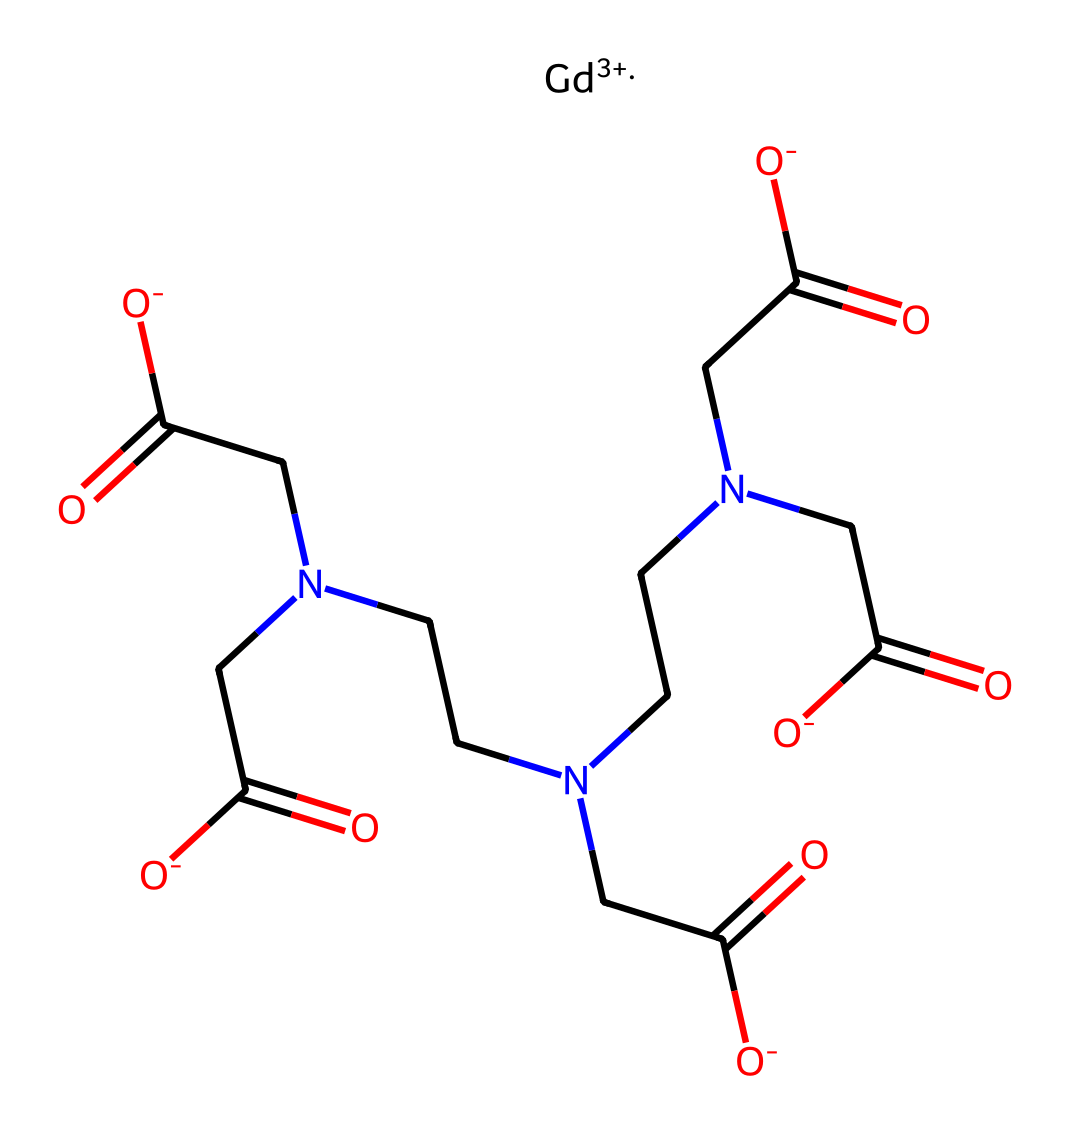How many nitrogen atoms are in the structure? The SMILES representation shows three instances of "N" which indicates that there are three nitrogen atoms present in the chemical structure.
Answer: three What is the charge of the gadolinium ion? In the SMILES, the notation "[Gd+3]" indicates that the gadolinium ion has a +3 charge.
Answer: +3 What functional groups are present in the chemical? The chemical structure includes carboxyl groups (-COOH) represented by "O=C([O-])" and acetamide groups in the amine sections indicated by "CN", which confirms the presence of both functional types.
Answer: carboxyl, amide What is the total number of carbon atoms in the molecule? By counting the instances of "C" in the SMILES representation and considering each explicit mention, there are 12 carbon atoms present in the entire structure.
Answer: 12 What type of compound does this chemical represent? The presence of gadolinium, a metal, along with multiple amine and carboxyl functionalities indicates that this compound is a gadolinium-based contrast agent used for imaging in MRI.
Answer: contrast agent Which part of this chemical structure is responsible for its MRI contrast properties? The gadolinium ion acts as the central atom in this compound and is responsible for enhancing contrast in MRI due to its paramagnetic properties.
Answer: gadolinium ion How many oxygen atoms are present in this chemical? The SMILES contains several instances of "O", specifically counting both the carboxylic groups and the hydroxyls reveals a total of 6 oxygen atoms within the structure.
Answer: 6 